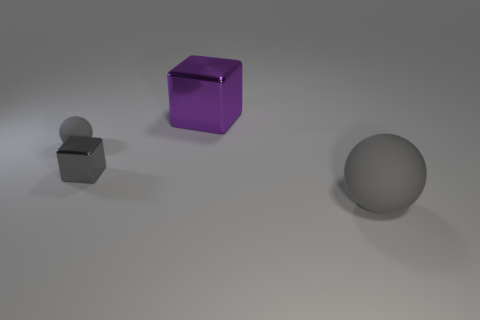Can you describe the lighting in the scene? The lighting in the image is soft and diffused, creating gentle shadows on the right side of the objects, which suggests a light source to the left outside the frame. The overall tone of the lighting is neutral, enhancing the reflective quality of the objects. 